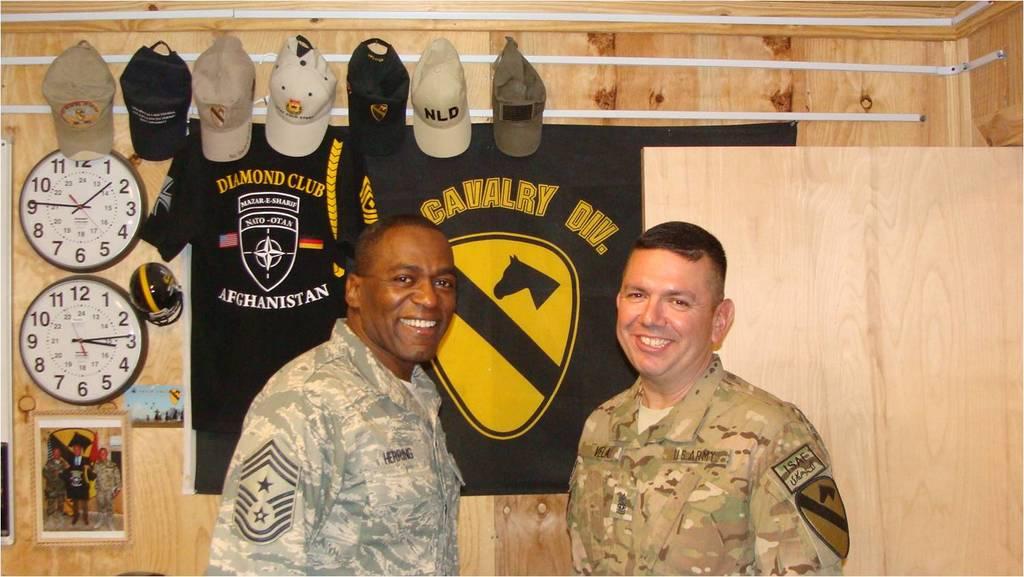What is the time shown on the clock on the bottom?
Your answer should be very brief. 3:14. What club is on the shirt on the left?
Your response must be concise. Diamond. 